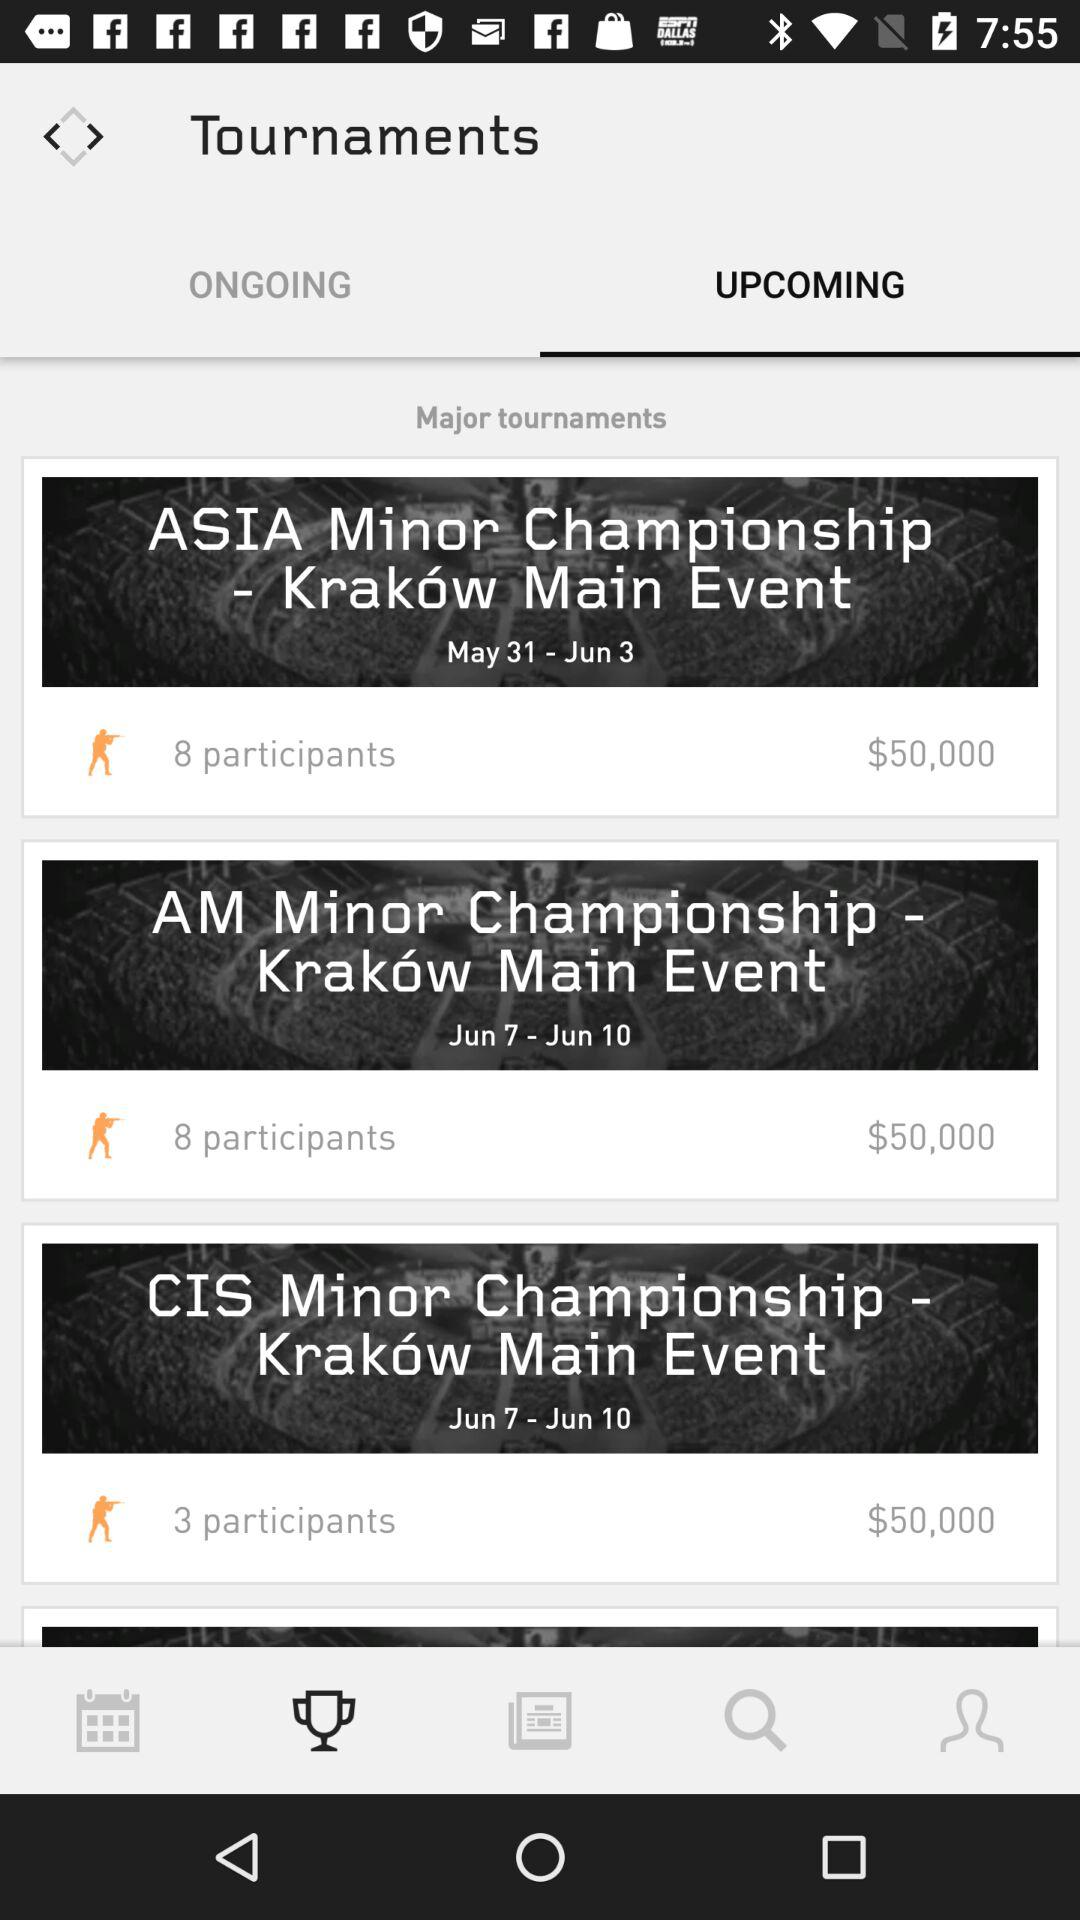What is the date range of the "AM Minor Championship"? The date range is from June 7 to June 10. 